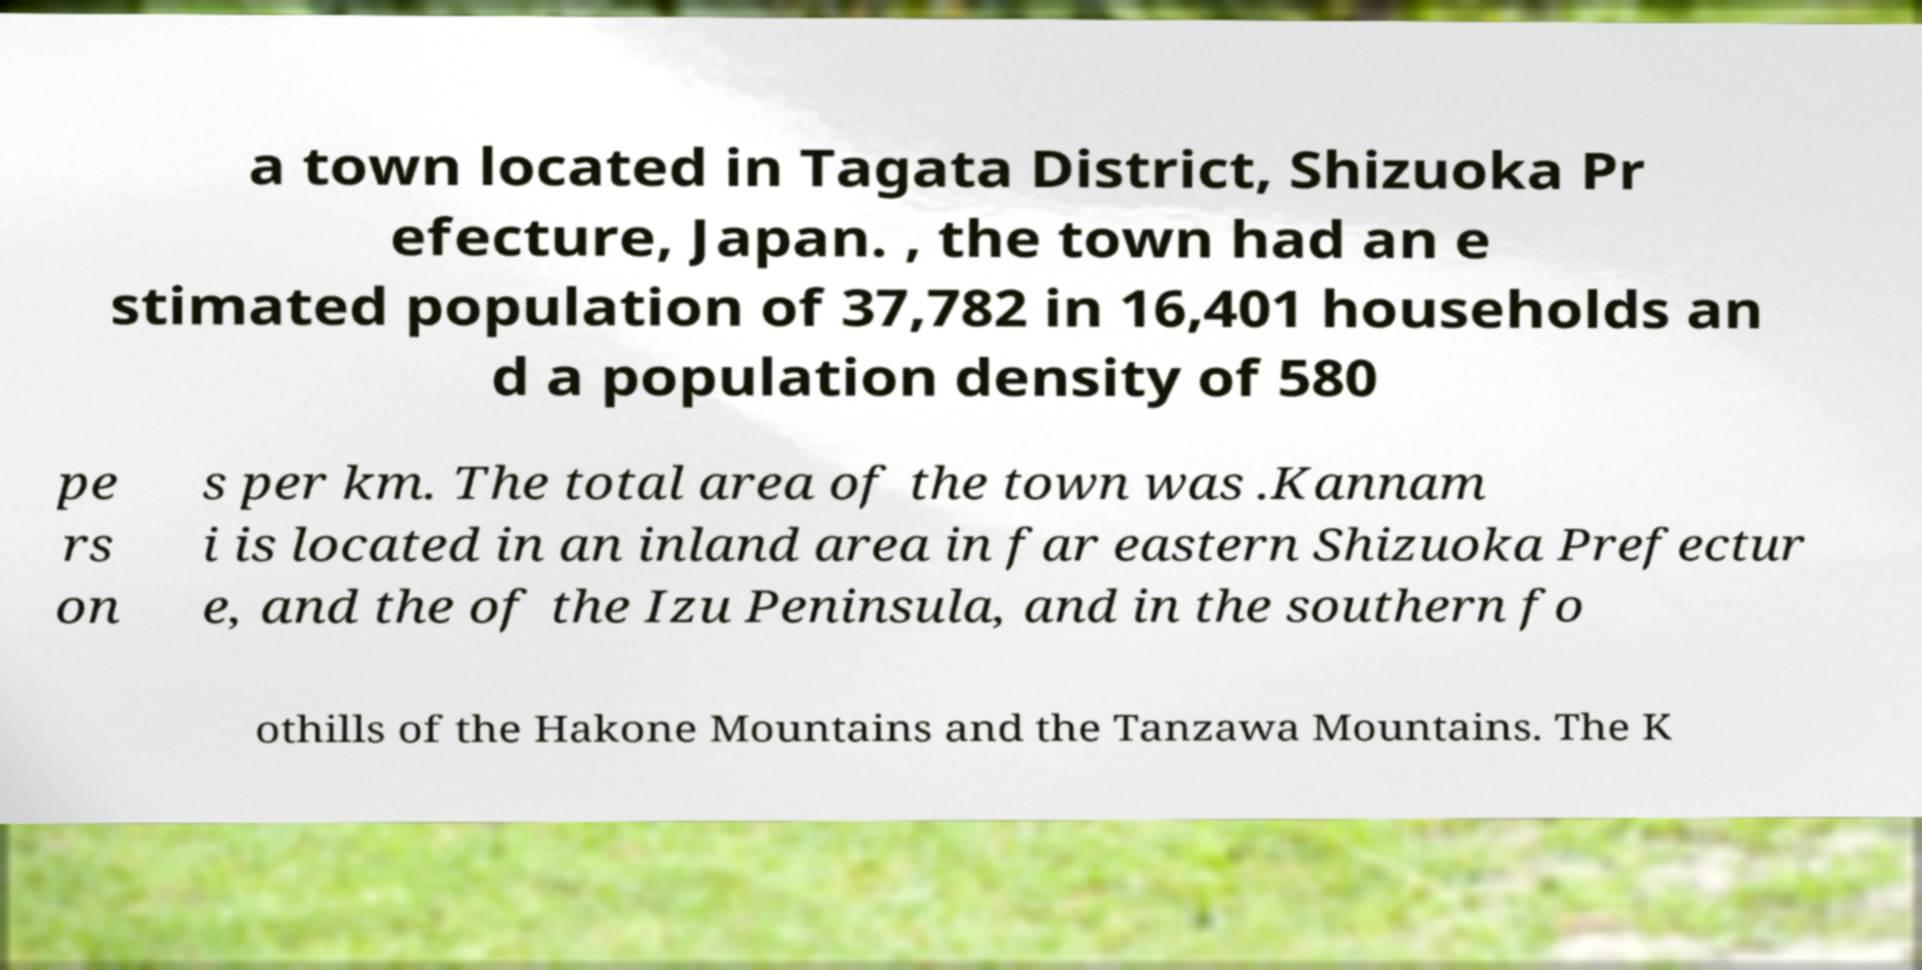I need the written content from this picture converted into text. Can you do that? a town located in Tagata District, Shizuoka Pr efecture, Japan. , the town had an e stimated population of 37,782 in 16,401 households an d a population density of 580 pe rs on s per km. The total area of the town was .Kannam i is located in an inland area in far eastern Shizuoka Prefectur e, and the of the Izu Peninsula, and in the southern fo othills of the Hakone Mountains and the Tanzawa Mountains. The K 